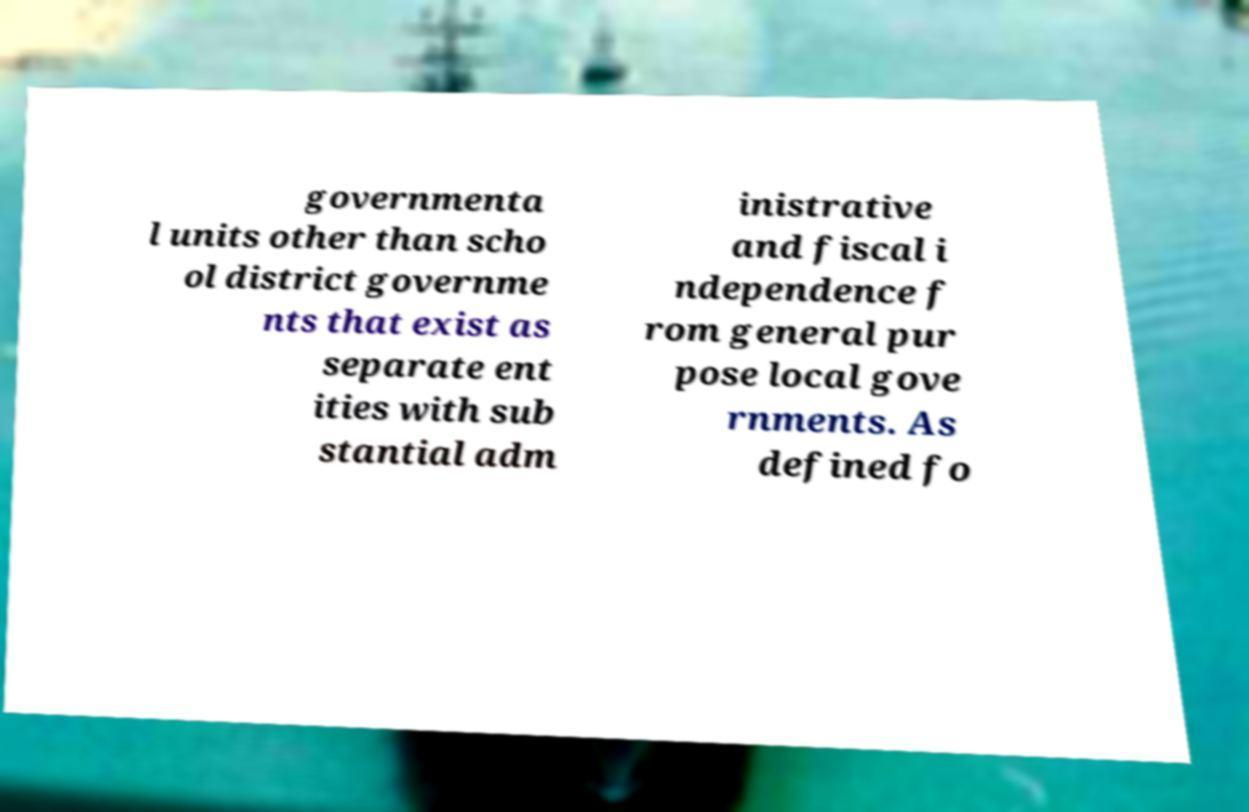Please identify and transcribe the text found in this image. governmenta l units other than scho ol district governme nts that exist as separate ent ities with sub stantial adm inistrative and fiscal i ndependence f rom general pur pose local gove rnments. As defined fo 